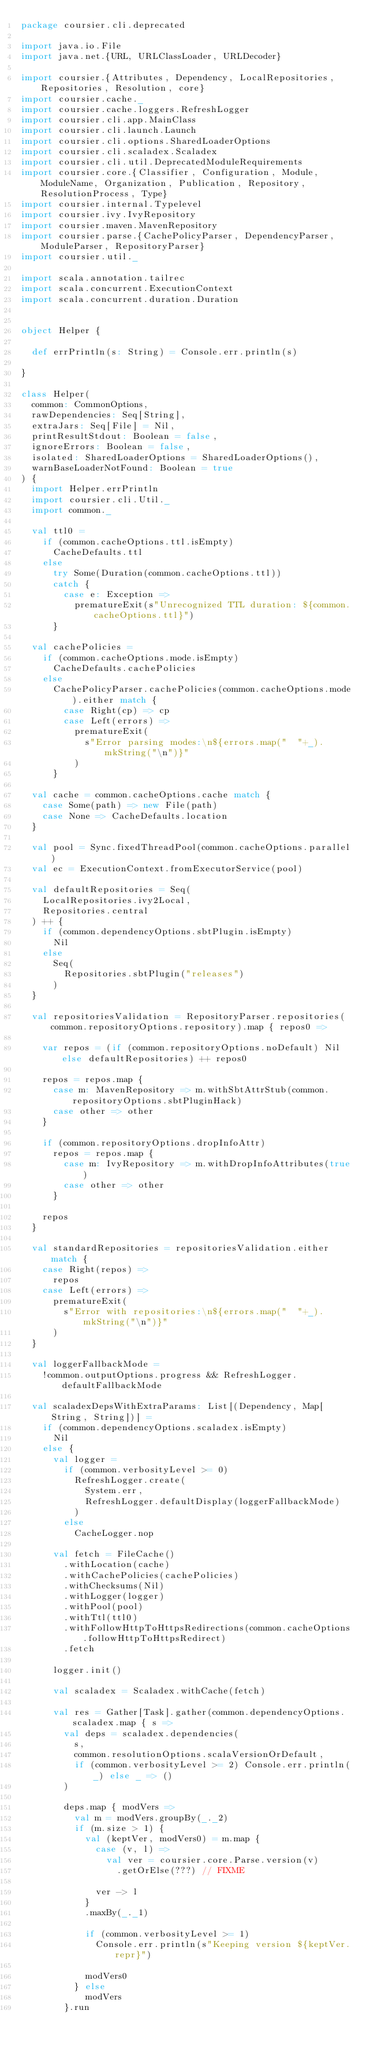Convert code to text. <code><loc_0><loc_0><loc_500><loc_500><_Scala_>package coursier.cli.deprecated

import java.io.File
import java.net.{URL, URLClassLoader, URLDecoder}

import coursier.{Attributes, Dependency, LocalRepositories, Repositories, Resolution, core}
import coursier.cache._
import coursier.cache.loggers.RefreshLogger
import coursier.cli.app.MainClass
import coursier.cli.launch.Launch
import coursier.cli.options.SharedLoaderOptions
import coursier.cli.scaladex.Scaladex
import coursier.cli.util.DeprecatedModuleRequirements
import coursier.core.{Classifier, Configuration, Module, ModuleName, Organization, Publication, Repository, ResolutionProcess, Type}
import coursier.internal.Typelevel
import coursier.ivy.IvyRepository
import coursier.maven.MavenRepository
import coursier.parse.{CachePolicyParser, DependencyParser, ModuleParser, RepositoryParser}
import coursier.util._

import scala.annotation.tailrec
import scala.concurrent.ExecutionContext
import scala.concurrent.duration.Duration


object Helper {

  def errPrintln(s: String) = Console.err.println(s)

}

class Helper(
  common: CommonOptions,
  rawDependencies: Seq[String],
  extraJars: Seq[File] = Nil,
  printResultStdout: Boolean = false,
  ignoreErrors: Boolean = false,
  isolated: SharedLoaderOptions = SharedLoaderOptions(),
  warnBaseLoaderNotFound: Boolean = true
) {
  import Helper.errPrintln
  import coursier.cli.Util._
  import common._

  val ttl0 =
    if (common.cacheOptions.ttl.isEmpty)
      CacheDefaults.ttl
    else
      try Some(Duration(common.cacheOptions.ttl))
      catch {
        case e: Exception =>
          prematureExit(s"Unrecognized TTL duration: ${common.cacheOptions.ttl}")
      }

  val cachePolicies =
    if (common.cacheOptions.mode.isEmpty)
      CacheDefaults.cachePolicies
    else
      CachePolicyParser.cachePolicies(common.cacheOptions.mode).either match {
        case Right(cp) => cp
        case Left(errors) =>
          prematureExit(
            s"Error parsing modes:\n${errors.map("  "+_).mkString("\n")}"
          )
      }

  val cache = common.cacheOptions.cache match {
    case Some(path) => new File(path)
    case None => CacheDefaults.location
  }

  val pool = Sync.fixedThreadPool(common.cacheOptions.parallel)
  val ec = ExecutionContext.fromExecutorService(pool)

  val defaultRepositories = Seq(
    LocalRepositories.ivy2Local,
    Repositories.central
  ) ++ {
    if (common.dependencyOptions.sbtPlugin.isEmpty)
      Nil
    else
      Seq(
        Repositories.sbtPlugin("releases")
      )
  }

  val repositoriesValidation = RepositoryParser.repositories(common.repositoryOptions.repository).map { repos0 =>

    var repos = (if (common.repositoryOptions.noDefault) Nil else defaultRepositories) ++ repos0

    repos = repos.map {
      case m: MavenRepository => m.withSbtAttrStub(common.repositoryOptions.sbtPluginHack)
      case other => other
    }

    if (common.repositoryOptions.dropInfoAttr)
      repos = repos.map {
        case m: IvyRepository => m.withDropInfoAttributes(true)
        case other => other
      }

    repos
  }

  val standardRepositories = repositoriesValidation.either match {
    case Right(repos) =>
      repos
    case Left(errors) =>
      prematureExit(
        s"Error with repositories:\n${errors.map("  "+_).mkString("\n")}"
      )
  }

  val loggerFallbackMode =
    !common.outputOptions.progress && RefreshLogger.defaultFallbackMode

  val scaladexDepsWithExtraParams: List[(Dependency, Map[String, String])] =
    if (common.dependencyOptions.scaladex.isEmpty)
      Nil
    else {
      val logger =
        if (common.verbosityLevel >= 0)
          RefreshLogger.create(
            System.err,
            RefreshLogger.defaultDisplay(loggerFallbackMode)
          )
        else
          CacheLogger.nop

      val fetch = FileCache()
        .withLocation(cache)
        .withCachePolicies(cachePolicies)
        .withChecksums(Nil)
        .withLogger(logger)
        .withPool(pool)
        .withTtl(ttl0)
        .withFollowHttpToHttpsRedirections(common.cacheOptions.followHttpToHttpsRedirect)
        .fetch

      logger.init()

      val scaladex = Scaladex.withCache(fetch)

      val res = Gather[Task].gather(common.dependencyOptions.scaladex.map { s =>
        val deps = scaladex.dependencies(
          s,
          common.resolutionOptions.scalaVersionOrDefault,
          if (common.verbosityLevel >= 2) Console.err.println(_) else _ => ()
        )

        deps.map { modVers =>
          val m = modVers.groupBy(_._2)
          if (m.size > 1) {
            val (keptVer, modVers0) = m.map {
              case (v, l) =>
                val ver = coursier.core.Parse.version(v)
                  .getOrElse(???) // FIXME

              ver -> l
            }
            .maxBy(_._1)

            if (common.verbosityLevel >= 1)
              Console.err.println(s"Keeping version ${keptVer.repr}")

            modVers0
          } else
            modVers
        }.run</code> 